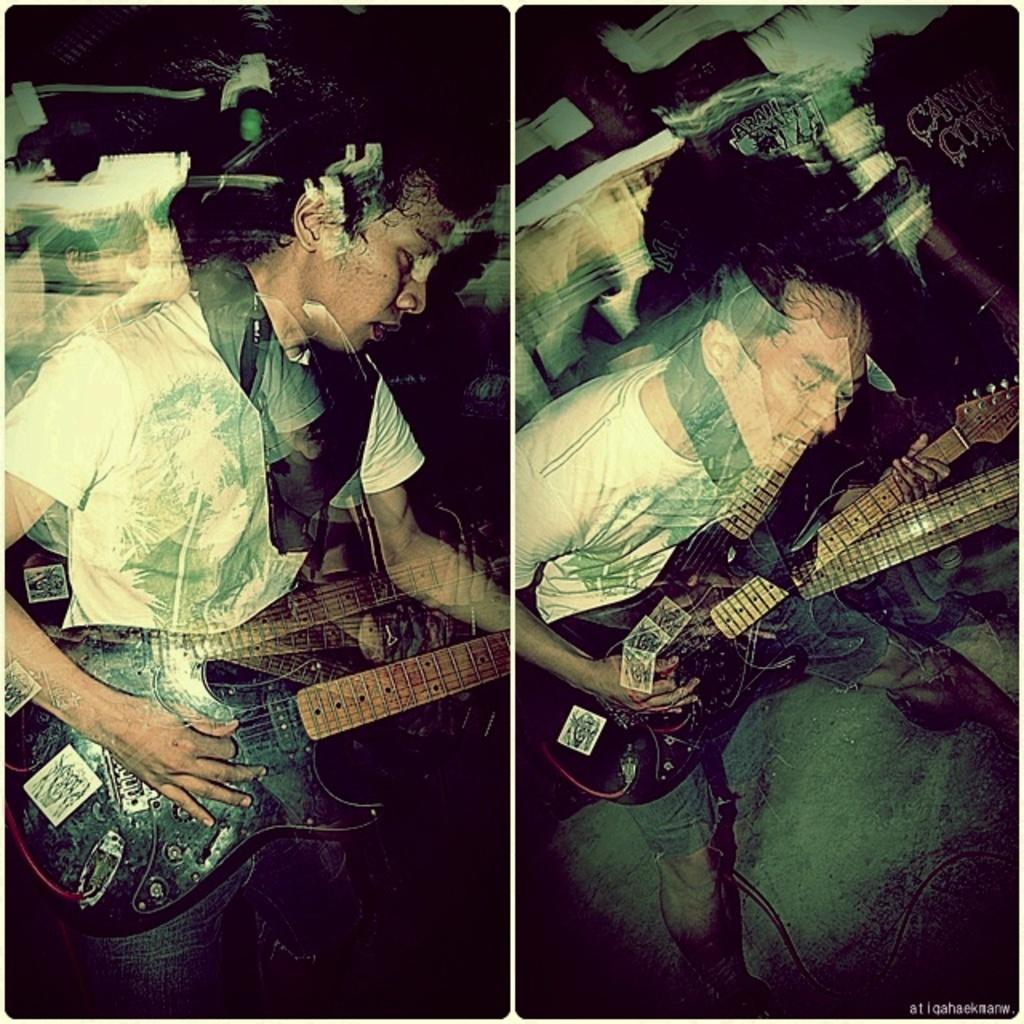What type of image is being described? The image is a collage. Has the image been altered in any way? Yes, the image has been edited. What are the people in the image doing? Both people in the image are holding guitars. Are the people in the image the same person? Yes, both people in the image are the same person. What is the name of the laborer in the image? There is no laborer present in the image. How many ducks are visible in the image? There are no ducks present in the image. 